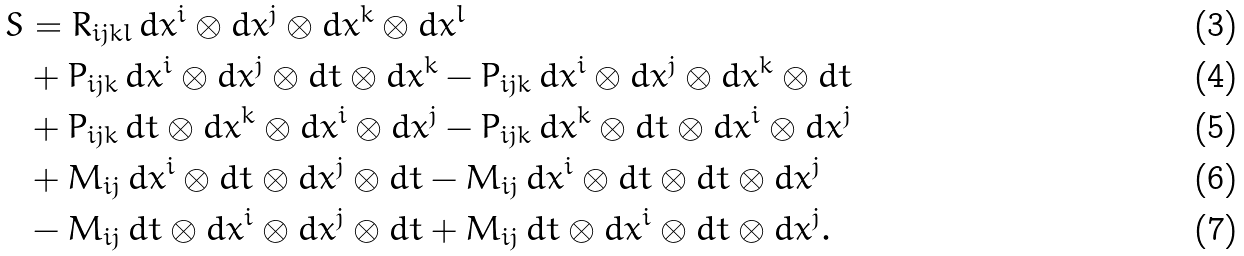Convert formula to latex. <formula><loc_0><loc_0><loc_500><loc_500>S & = R _ { i j k l } \, d x ^ { i } \otimes d x ^ { j } \otimes d x ^ { k } \otimes d x ^ { l } \\ & + P _ { i j k } \, d x ^ { i } \otimes d x ^ { j } \otimes d t \otimes d x ^ { k } - P _ { i j k } \, d x ^ { i } \otimes d x ^ { j } \otimes d x ^ { k } \otimes d t \\ & + P _ { i j k } \, d t \otimes d x ^ { k } \otimes d x ^ { i } \otimes d x ^ { j } - P _ { i j k } \, d x ^ { k } \otimes d t \otimes d x ^ { i } \otimes d x ^ { j } \\ & + M _ { i j } \, d x ^ { i } \otimes d t \otimes d x ^ { j } \otimes d t - M _ { i j } \, d x ^ { i } \otimes d t \otimes d t \otimes d x ^ { j } \\ & - M _ { i j } \, d t \otimes d x ^ { i } \otimes d x ^ { j } \otimes d t + M _ { i j } \, d t \otimes d x ^ { i } \otimes d t \otimes d x ^ { j } .</formula> 